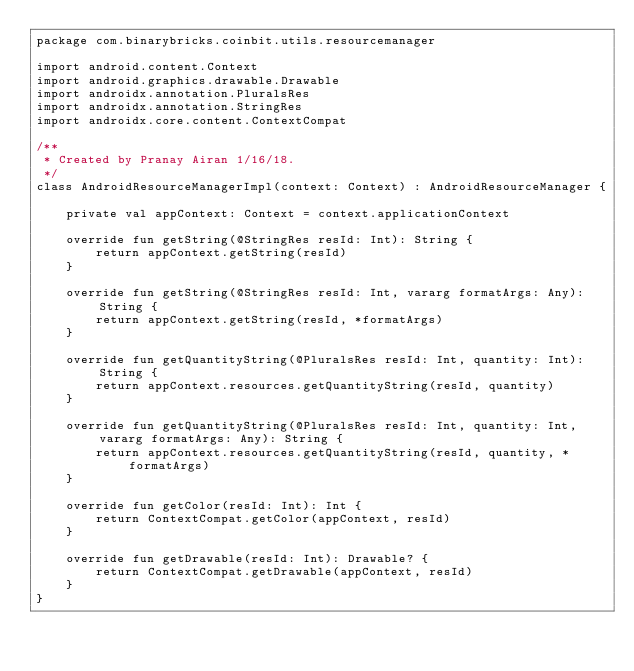<code> <loc_0><loc_0><loc_500><loc_500><_Kotlin_>package com.binarybricks.coinbit.utils.resourcemanager

import android.content.Context
import android.graphics.drawable.Drawable
import androidx.annotation.PluralsRes
import androidx.annotation.StringRes
import androidx.core.content.ContextCompat

/**
 * Created by Pranay Airan 1/16/18.
 */
class AndroidResourceManagerImpl(context: Context) : AndroidResourceManager {

    private val appContext: Context = context.applicationContext

    override fun getString(@StringRes resId: Int): String {
        return appContext.getString(resId)
    }

    override fun getString(@StringRes resId: Int, vararg formatArgs: Any): String {
        return appContext.getString(resId, *formatArgs)
    }

    override fun getQuantityString(@PluralsRes resId: Int, quantity: Int): String {
        return appContext.resources.getQuantityString(resId, quantity)
    }

    override fun getQuantityString(@PluralsRes resId: Int, quantity: Int, vararg formatArgs: Any): String {
        return appContext.resources.getQuantityString(resId, quantity, *formatArgs)
    }

    override fun getColor(resId: Int): Int {
        return ContextCompat.getColor(appContext, resId)
    }

    override fun getDrawable(resId: Int): Drawable? {
        return ContextCompat.getDrawable(appContext, resId)
    }
}
</code> 